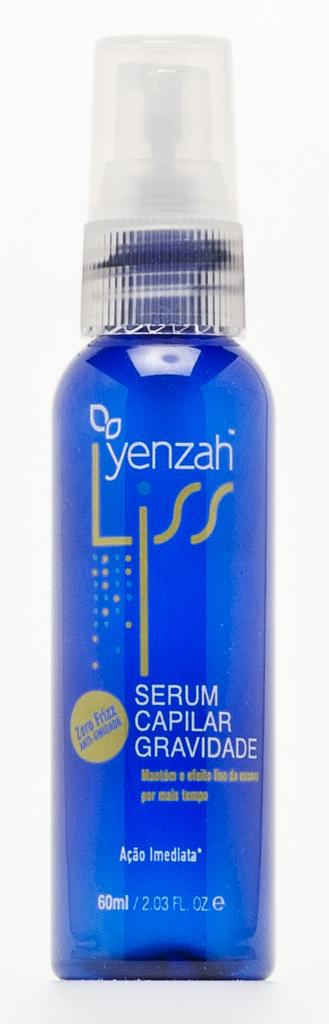<image>
Give a short and clear explanation of the subsequent image. A bottle containing a blue product and made by Yenzah. 